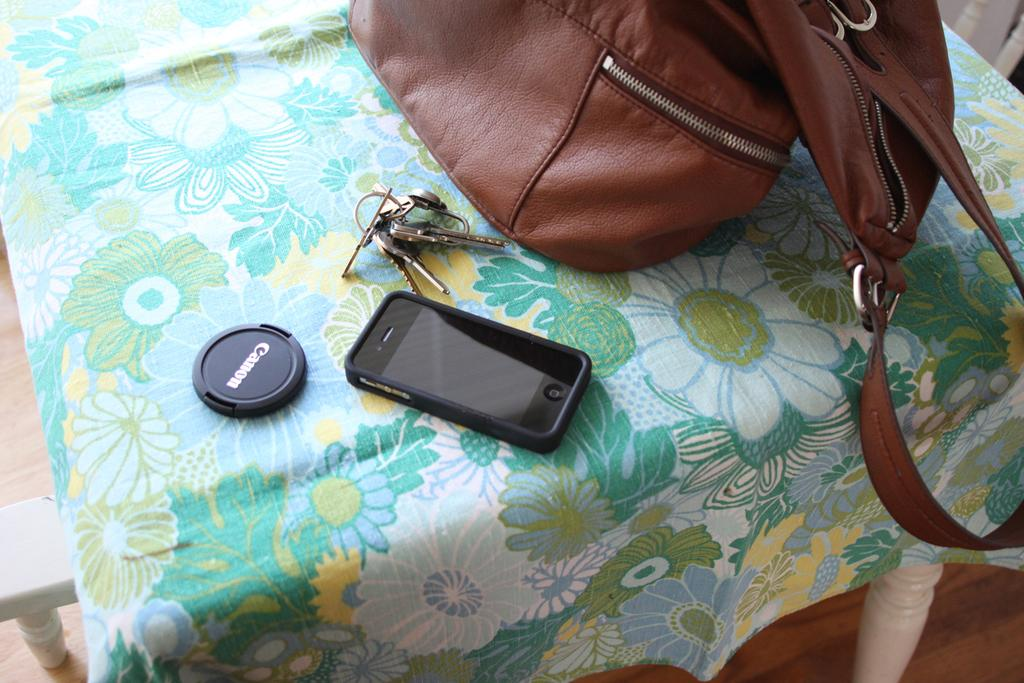What piece of furniture is present in the image? There is a table in the image. What is covering the table? The table has a cloth on it. What type of object can be seen in the image, besides the table? There is a bag, keys, a phone, and a camera cap in the image. What color is the bag? The bag is brown in color. What color is the phone? The phone is black in color. What accessory is related to the camera in the image? There is a camera cap in the image. What does the brother say to the dad in the image? There is no brother or dad present in the image, so there is no conversation to describe. 